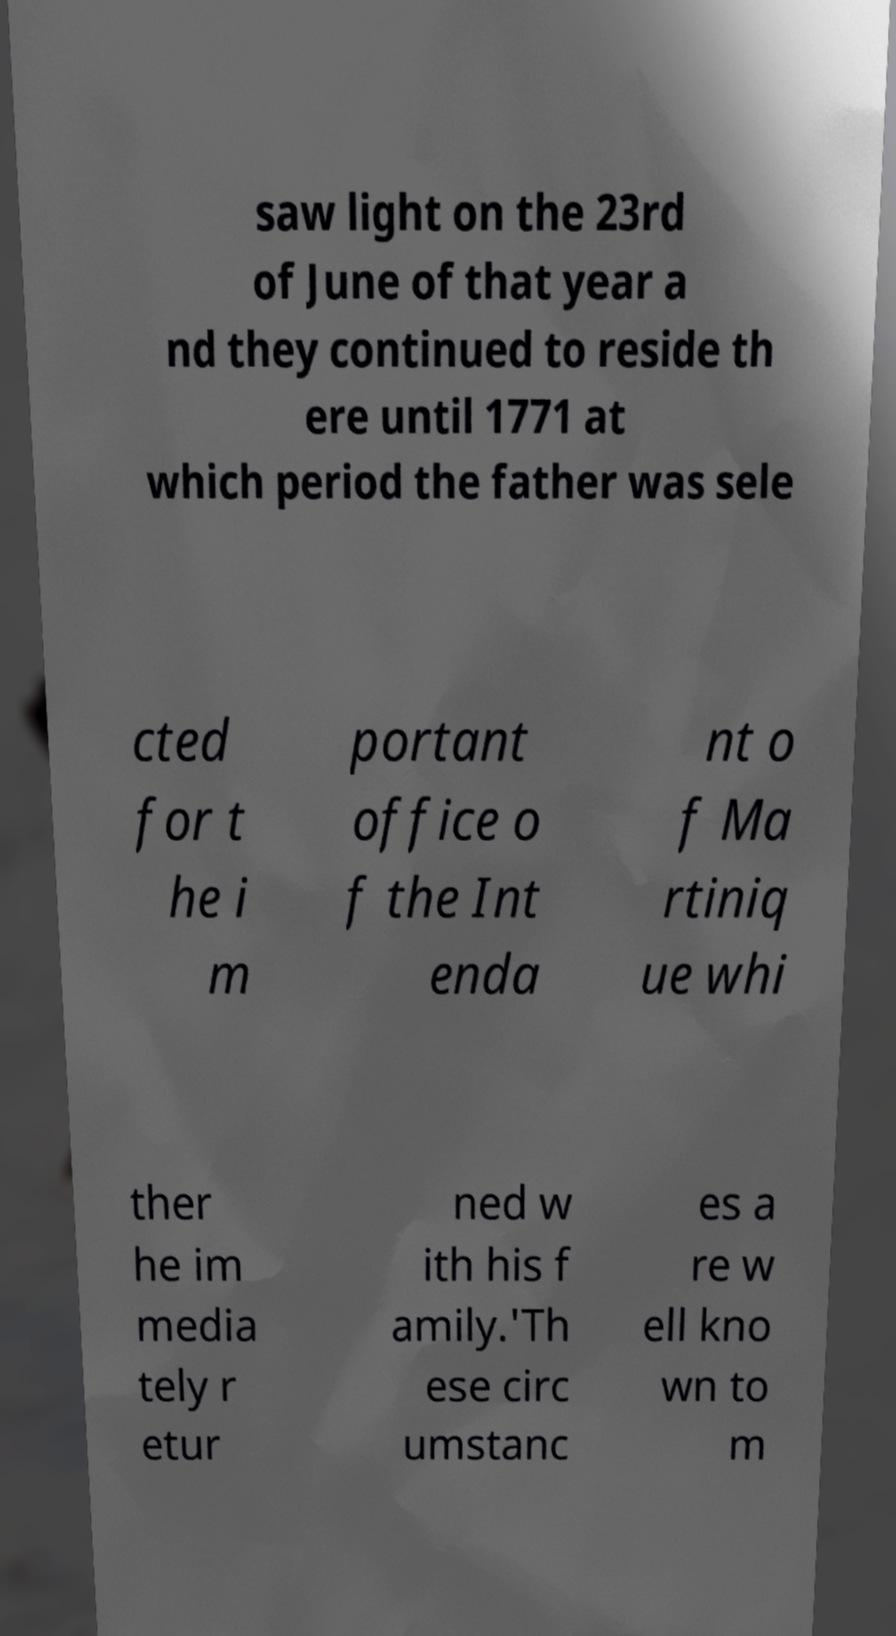Please identify and transcribe the text found in this image. saw light on the 23rd of June of that year a nd they continued to reside th ere until 1771 at which period the father was sele cted for t he i m portant office o f the Int enda nt o f Ma rtiniq ue whi ther he im media tely r etur ned w ith his f amily.'Th ese circ umstanc es a re w ell kno wn to m 